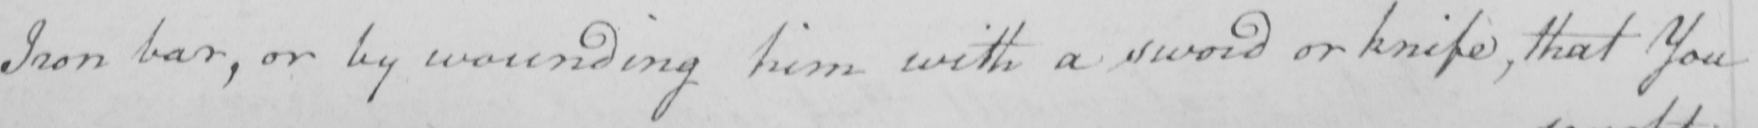Please transcribe the handwritten text in this image. Iron bar , or by wounding him with a sword or knife , that You 